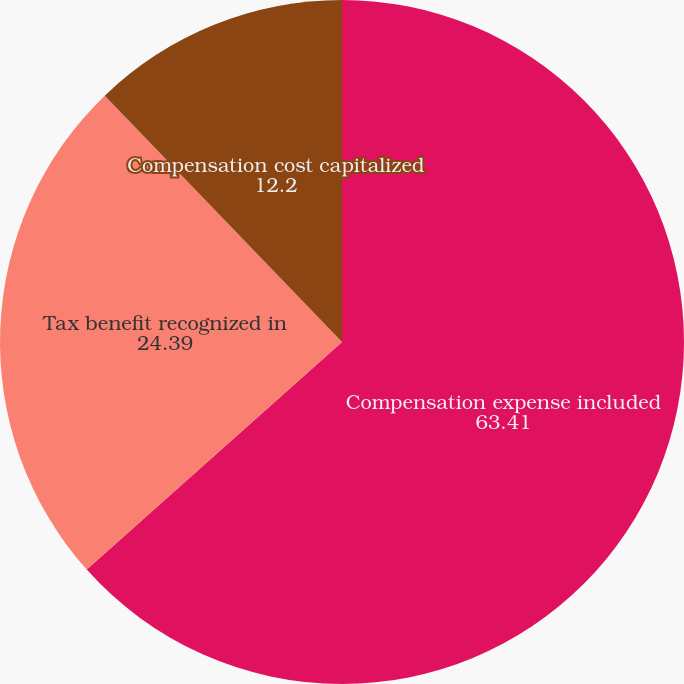<chart> <loc_0><loc_0><loc_500><loc_500><pie_chart><fcel>Compensation expense included<fcel>Tax benefit recognized in<fcel>Compensation cost capitalized<nl><fcel>63.41%<fcel>24.39%<fcel>12.2%<nl></chart> 